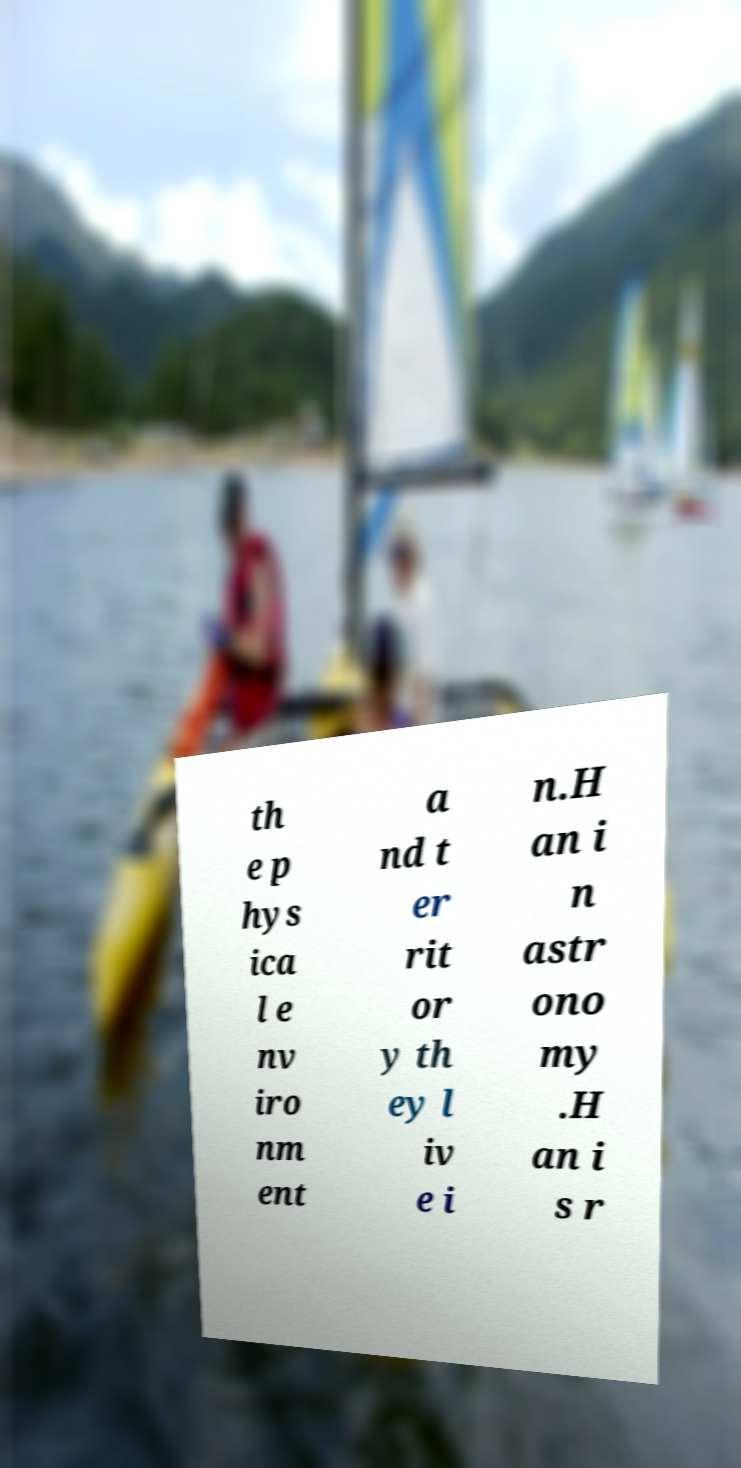Can you accurately transcribe the text from the provided image for me? th e p hys ica l e nv iro nm ent a nd t er rit or y th ey l iv e i n.H an i n astr ono my .H an i s r 